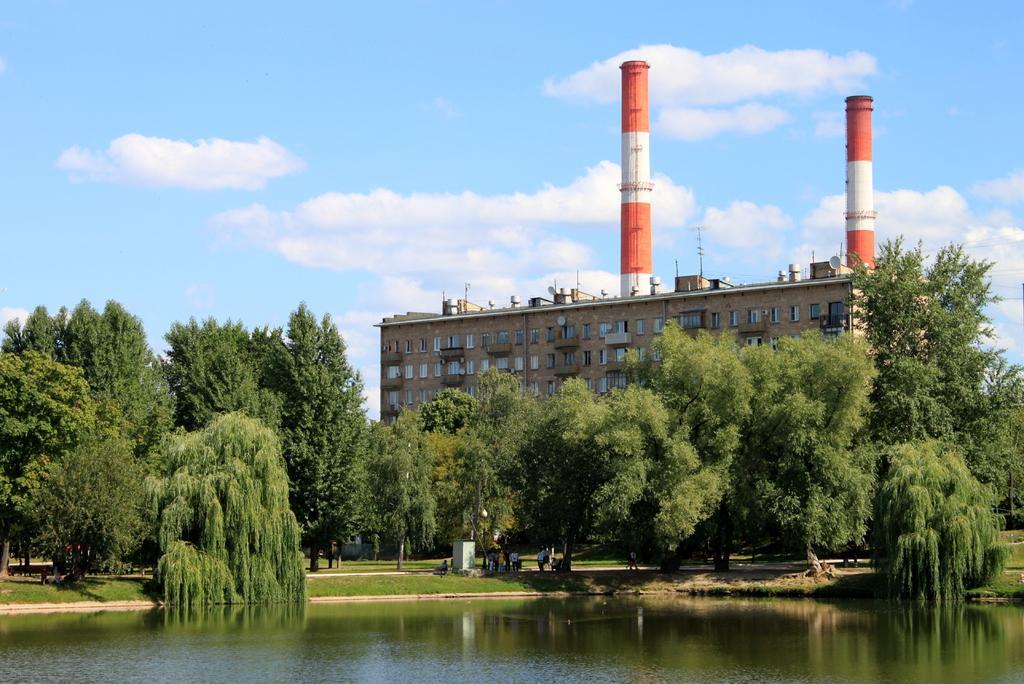Please provide a concise description of this image. At the bottom of the image there is water. Behind the water there is a ground with grass and also there are many trees. Behind them there is a building with walls, windows and there are two poles with red and white color. At the top of the image there is a sky with clouds. 